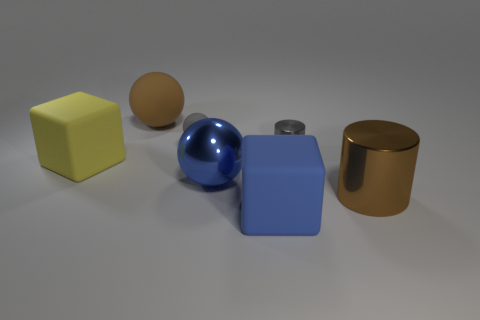There is a gray object that is left of the small gray thing that is to the right of the big metallic object left of the large brown metal object; how big is it?
Give a very brief answer. Small. Do the yellow object and the gray rubber object have the same size?
Give a very brief answer. No. What material is the cube to the left of the large brown thing behind the gray metallic object?
Your answer should be very brief. Rubber. Do the blue thing behind the blue matte object and the brown thing that is in front of the large yellow block have the same shape?
Provide a succinct answer. No. Are there an equal number of yellow rubber blocks that are left of the large yellow rubber cube and blue rubber cylinders?
Ensure brevity in your answer.  Yes. There is a big brown thing that is behind the large cylinder; are there any large metallic things that are in front of it?
Offer a very short reply. Yes. Is there any other thing of the same color as the big cylinder?
Offer a very short reply. Yes. Do the large sphere to the right of the tiny matte sphere and the blue block have the same material?
Make the answer very short. No. Are there the same number of tiny metallic cylinders that are on the left side of the big blue block and spheres to the right of the small gray metallic object?
Ensure brevity in your answer.  Yes. What is the size of the rubber block that is behind the rubber cube that is to the right of the tiny sphere?
Ensure brevity in your answer.  Large. 